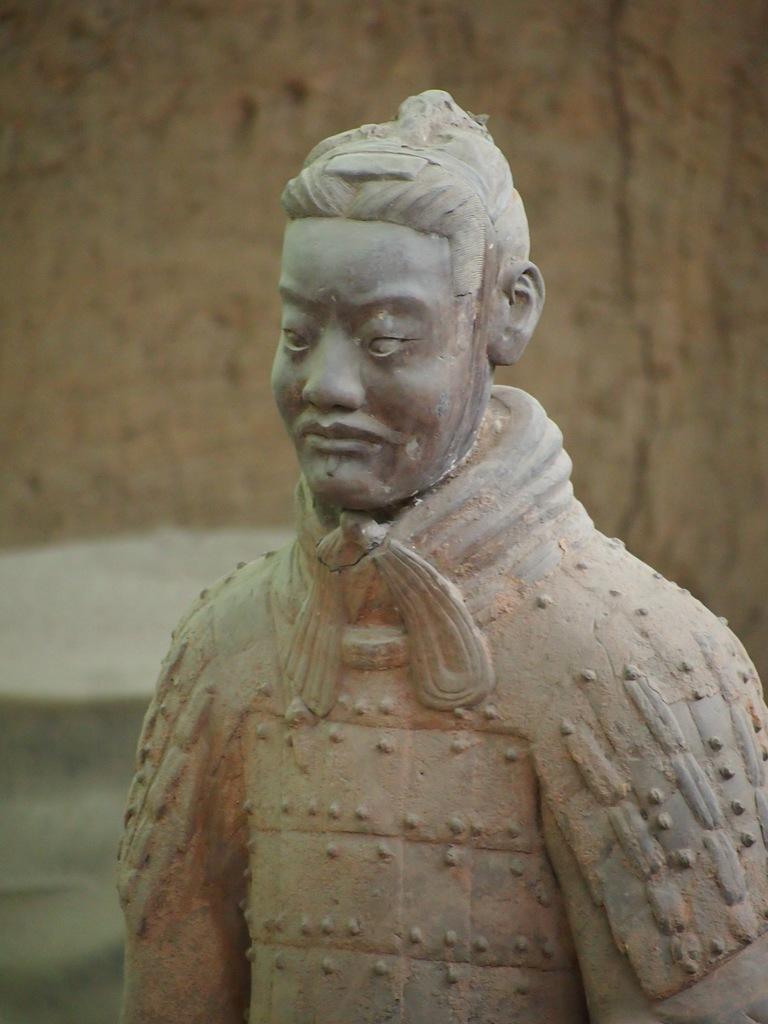Can you describe this image briefly? In the image we can see there is a statue of a person. 